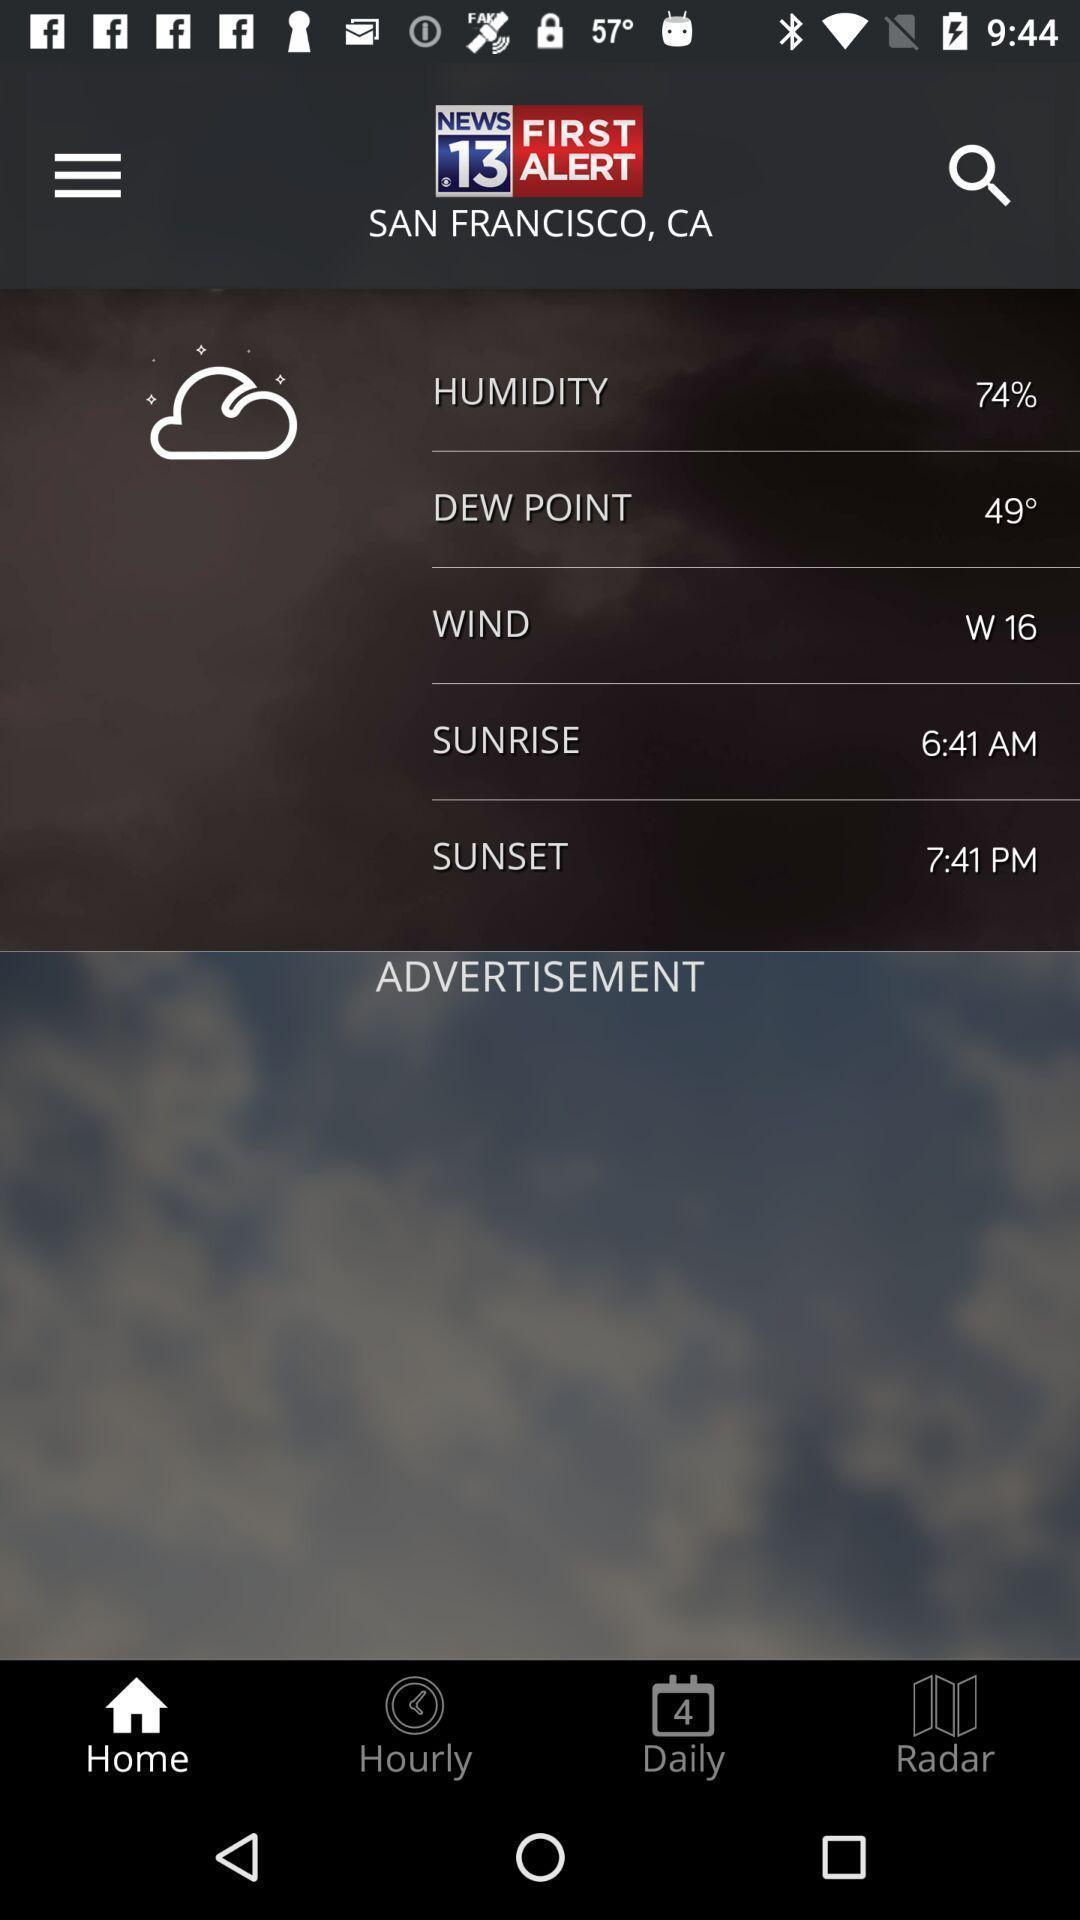Summarize the main components in this picture. Window displaying weather forecast app. 